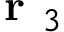<formula> <loc_0><loc_0><loc_500><loc_500>r _ { 3 }</formula> 